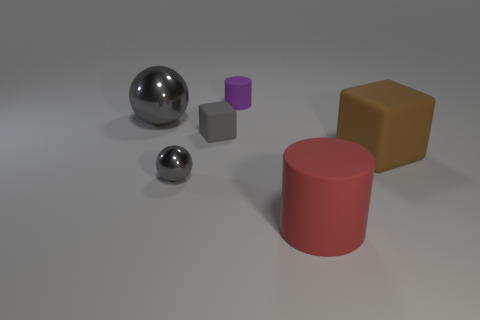What is the shape of the matte thing on the left side of the rubber cylinder behind the red rubber cylinder?
Offer a terse response. Cube. There is a cylinder that is behind the gray ball left of the ball that is in front of the brown thing; what is its size?
Offer a terse response. Small. There is another object that is the same shape as the small metallic thing; what color is it?
Ensure brevity in your answer.  Gray. Do the brown rubber object and the purple rubber thing have the same size?
Your response must be concise. No. What is the gray object in front of the small gray rubber thing made of?
Offer a very short reply. Metal. How many other objects are the same shape as the red matte object?
Ensure brevity in your answer.  1. Is the large gray metallic thing the same shape as the tiny gray shiny object?
Offer a terse response. Yes. There is a small metallic thing; are there any things on the left side of it?
Give a very brief answer. Yes. How many objects are cyan metal balls or tiny purple matte cylinders?
Offer a terse response. 1. How many other objects are the same size as the red object?
Keep it short and to the point. 2. 